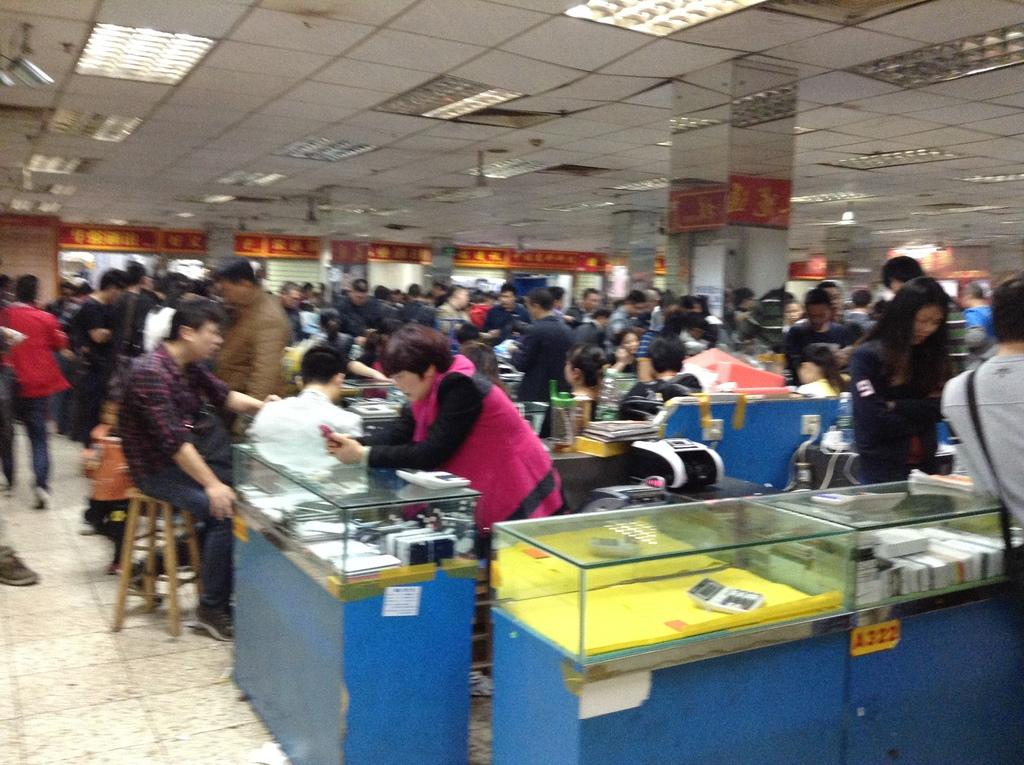What type of structure can be seen in the image? There are counters in the image. Who or what is present in the image? There are people in the image. What is visible at the top of the image? The ceiling with lights is visible at the top of the image. What is visible at the bottom of the image? The floor is visible at the bottom of the image. Can you see any beads on the floor in the image? There is no mention of beads in the image, so we cannot determine if any are present on the floor. What direction are the people in the image looking? The image does not provide information about the direction the people are looking, so we cannot answer this question. 